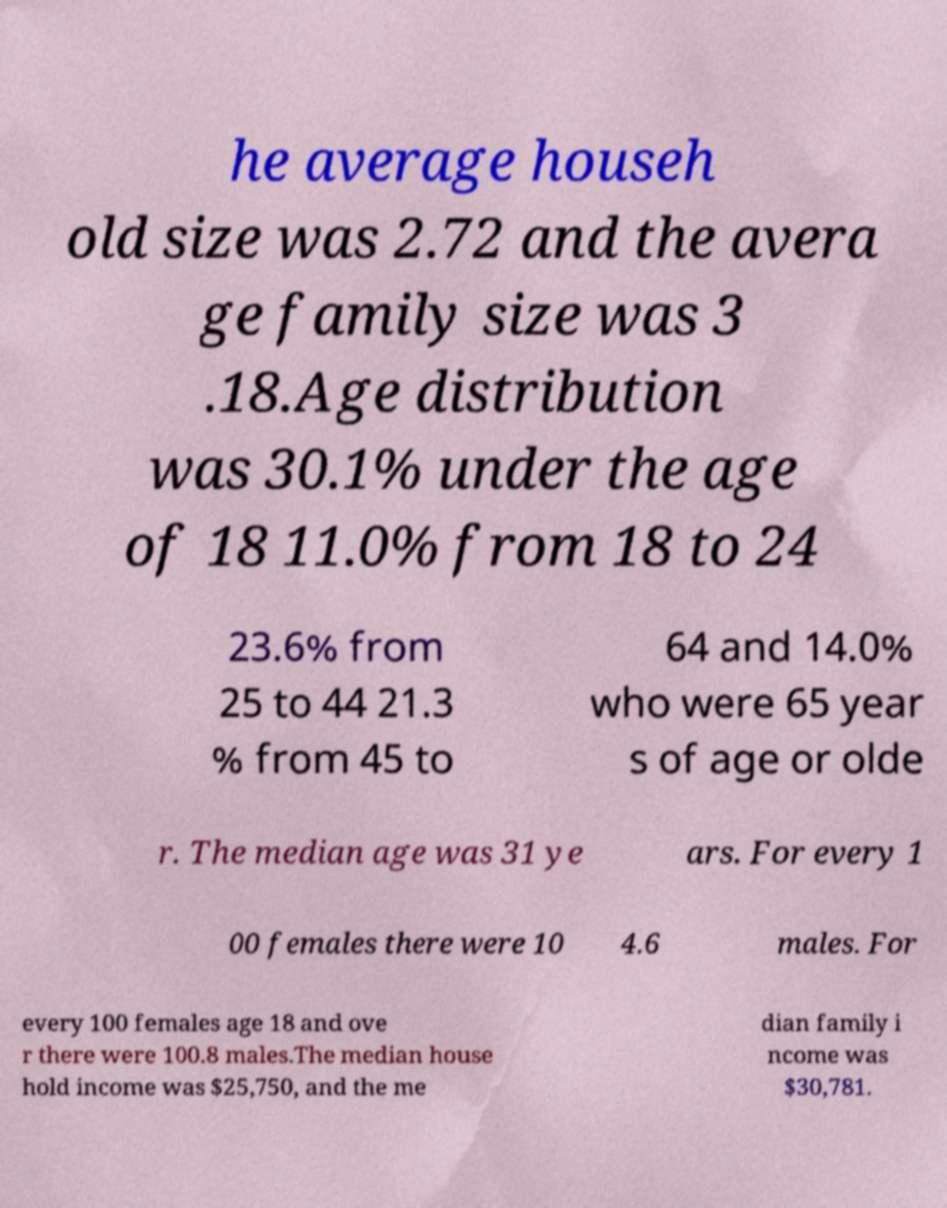Please identify and transcribe the text found in this image. he average househ old size was 2.72 and the avera ge family size was 3 .18.Age distribution was 30.1% under the age of 18 11.0% from 18 to 24 23.6% from 25 to 44 21.3 % from 45 to 64 and 14.0% who were 65 year s of age or olde r. The median age was 31 ye ars. For every 1 00 females there were 10 4.6 males. For every 100 females age 18 and ove r there were 100.8 males.The median house hold income was $25,750, and the me dian family i ncome was $30,781. 